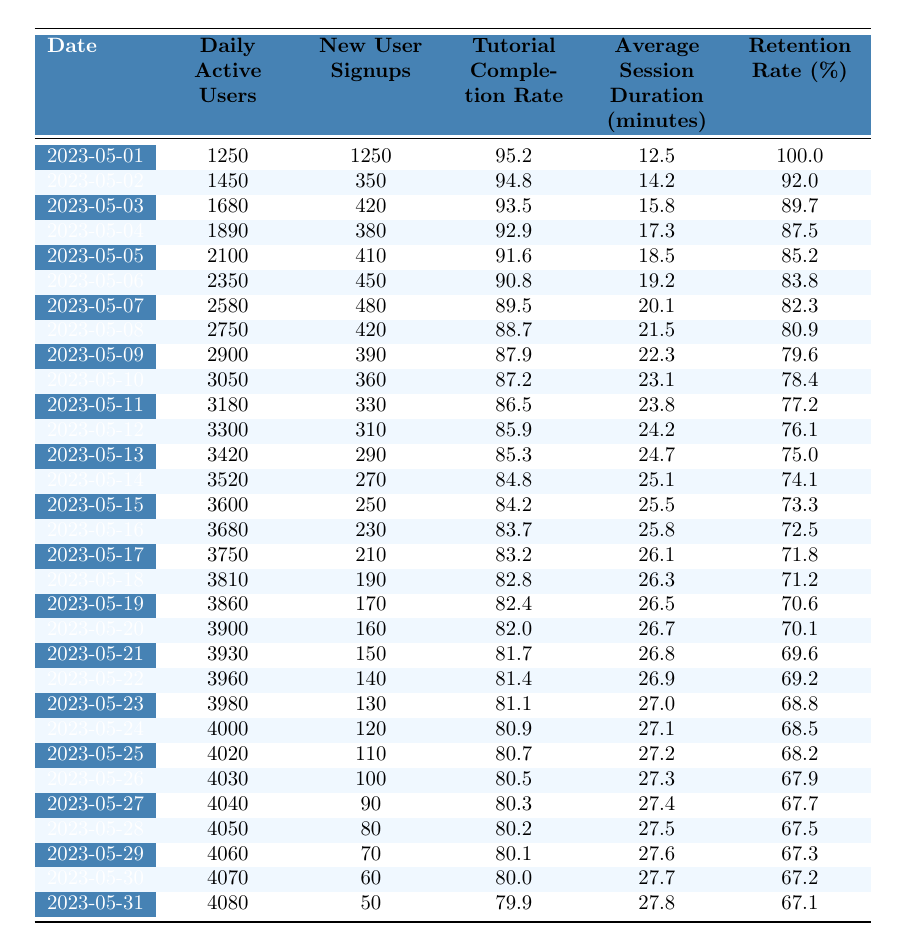What was the average daily active user count for the first week? The user counts for the first week are: 1250, 1450, 1680, 1890, 2100, 2350, and 2580. Summing these gives 1250 + 1450 + 1680 + 1890 + 2100 + 2350 + 2580 = 13300. Dividing by 7 (the number of days) gives an average of 1900.
Answer: 1900 What was the retention rate on May 10th? The retention rate on May 10th is listed directly in the table as 78.4%.
Answer: 78.4% On which date did the game achieve its highest number of daily active users? By examining the "Daily Active Users" column, the highest value is 4080 on May 31st.
Answer: May 31st Did the tutorial completion rate remain above 85% throughout the month? The table shows the tutorial completion rates for each day, with values below 85% starting from May 15th. Therefore, the statement is false.
Answer: No What is the difference between the daily active users on May 1st and May 31st? The daily active users on May 1st were 1250 and on May 31st were 4080. The difference is 4080 - 1250 = 2830.
Answer: 2830 What was the trend in new user signups from May 1st to May 31st? New user signups started at 1250 and consistently decreased each day, ending at 50 on May 31st, indicating a downward trend.
Answer: Decreasing trend What was the average session duration across the month? To find the average session duration, sum the daily durations: (12.5 + 14.2 + 15.8 + 17.3 + 18.5 + 19.2 + 20.1 + 21.5 + 22.3 + 23.1 + 23.8 + 24.2 + 24.7 + 25.1 + 25.5 + 25.8 + 26.1 + 26.3 + 26.5 + 26.7 + 26.8 + 26.9 + 27.0 + 27.1 + 27.2 + 27.3 + 27.4 + 27.5 + 27.6 + 27.7 + 27.8) = 777.1, then divide by 31, resulting in an average of about 25.06.
Answer: 25.06 What was the average retention rate over the month? The retention rates are: 100.0, 92.0, 89.7, 87.5, 85.2, 83.8, 82.3, 80.9, 79.6, 78.4, 77.2, 76.1, 75.0, 74.1, 73.3, 72.5, 71.8, 71.2, 70.6, 70.1, 69.6, 69.2, 68.8, 68.5, 68.2, 67.9, 67.7, 67.5, 67.3, 67.2, 67.1. Summing these gives 2231.7, and dividing by 31 gives approximately 71.59.
Answer: 71.59 How many days did the average session duration exceed 26 minutes? By analyzing the "Average Session Duration" values, it exceeds 26 minutes on May 18th (26.1), May 19th (26.5), May 20th (26.7), May 21st (26.8), May 22nd (26.9), May 23rd (27.0), May 24th (27.1), May 25th (27.2), May 26th (27.3), May 27th (27.4), May 28th (27.5), May 29th (27.6), May 30th (27.7), and May 31st (27.8). That totals 14 days.
Answer: 14 days Did daily active users hit 4000 before May 31st? Checking the "Daily Active Users" column, the value first reaches 4000 on May 24th, which is before May 31st, so the answer is yes.
Answer: Yes 